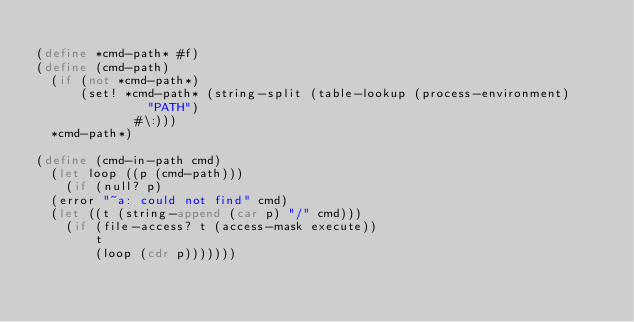<code> <loc_0><loc_0><loc_500><loc_500><_Scheme_>
(define *cmd-path* #f)
(define (cmd-path)
  (if (not *cmd-path*)
      (set! *cmd-path* (string-split (table-lookup (process-environment)
						   "PATH")
				     #\:)))
  *cmd-path*)

(define (cmd-in-path cmd)
  (let loop ((p (cmd-path)))
    (if (null? p)
	(error "~a: could not find" cmd)
	(let ((t (string-append (car p) "/" cmd)))
	  (if (file-access? t (access-mask execute))
	      t
	      (loop (cdr p)))))))

</code> 